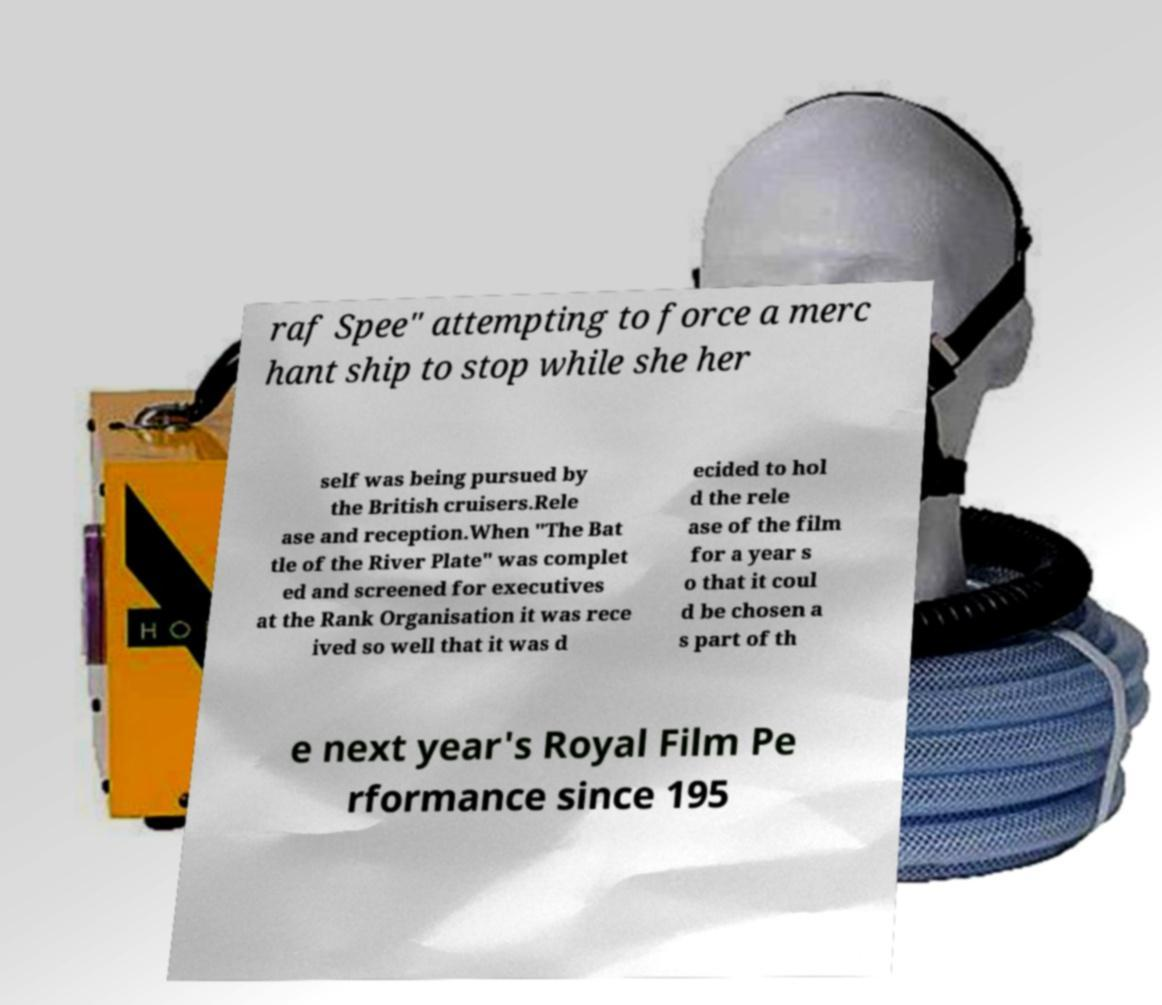For documentation purposes, I need the text within this image transcribed. Could you provide that? raf Spee" attempting to force a merc hant ship to stop while she her self was being pursued by the British cruisers.Rele ase and reception.When "The Bat tle of the River Plate" was complet ed and screened for executives at the Rank Organisation it was rece ived so well that it was d ecided to hol d the rele ase of the film for a year s o that it coul d be chosen a s part of th e next year's Royal Film Pe rformance since 195 